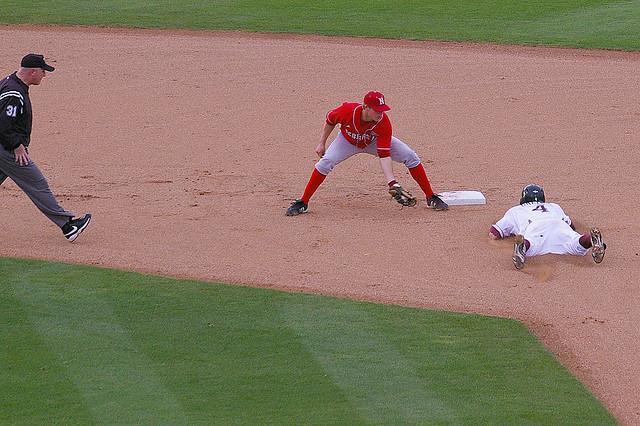How many people are there?
Give a very brief answer. 3. How many horses are shown?
Give a very brief answer. 0. 